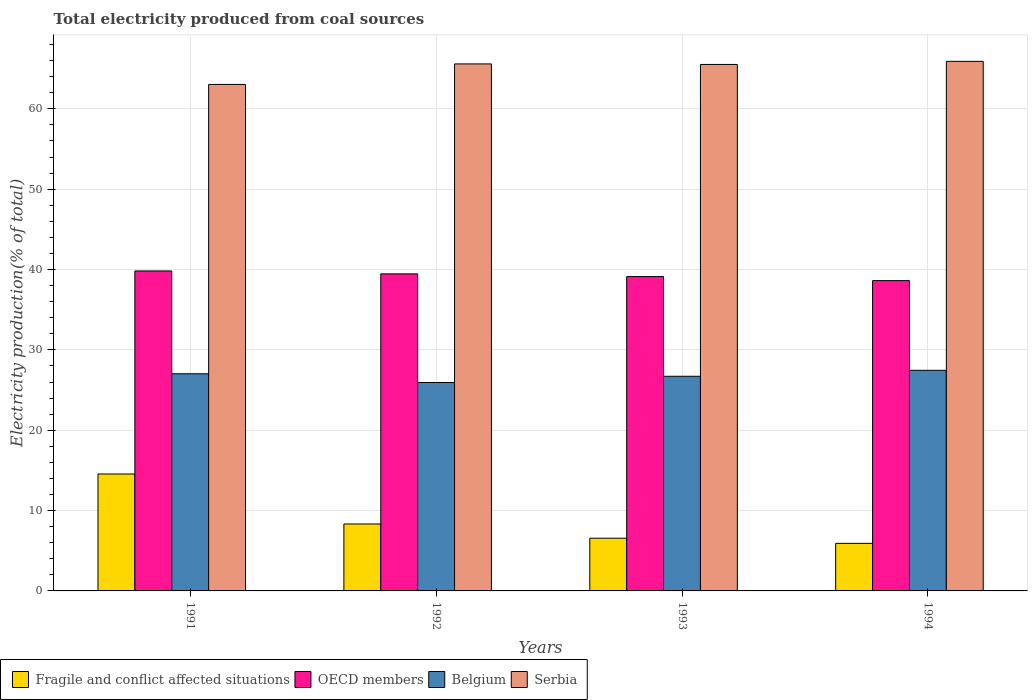How many groups of bars are there?
Your response must be concise. 4. Are the number of bars per tick equal to the number of legend labels?
Your answer should be very brief. Yes. Are the number of bars on each tick of the X-axis equal?
Your answer should be compact. Yes. In how many cases, is the number of bars for a given year not equal to the number of legend labels?
Give a very brief answer. 0. What is the total electricity produced in Serbia in 1993?
Ensure brevity in your answer.  65.52. Across all years, what is the maximum total electricity produced in Belgium?
Your response must be concise. 27.45. Across all years, what is the minimum total electricity produced in Fragile and conflict affected situations?
Provide a succinct answer. 5.92. In which year was the total electricity produced in Belgium minimum?
Make the answer very short. 1992. What is the total total electricity produced in OECD members in the graph?
Make the answer very short. 157.02. What is the difference between the total electricity produced in Belgium in 1993 and that in 1994?
Your response must be concise. -0.74. What is the difference between the total electricity produced in Serbia in 1992 and the total electricity produced in Fragile and conflict affected situations in 1991?
Ensure brevity in your answer.  51.04. What is the average total electricity produced in Serbia per year?
Give a very brief answer. 65.01. In the year 1992, what is the difference between the total electricity produced in OECD members and total electricity produced in Serbia?
Your answer should be compact. -26.13. In how many years, is the total electricity produced in Belgium greater than 20 %?
Make the answer very short. 4. What is the ratio of the total electricity produced in Fragile and conflict affected situations in 1991 to that in 1992?
Keep it short and to the point. 1.75. What is the difference between the highest and the second highest total electricity produced in Fragile and conflict affected situations?
Make the answer very short. 6.22. What is the difference between the highest and the lowest total electricity produced in Serbia?
Ensure brevity in your answer.  2.87. Is it the case that in every year, the sum of the total electricity produced in OECD members and total electricity produced in Serbia is greater than the sum of total electricity produced in Belgium and total electricity produced in Fragile and conflict affected situations?
Your answer should be very brief. No. What does the 3rd bar from the left in 1992 represents?
Make the answer very short. Belgium. Is it the case that in every year, the sum of the total electricity produced in Serbia and total electricity produced in Fragile and conflict affected situations is greater than the total electricity produced in Belgium?
Offer a terse response. Yes. Are all the bars in the graph horizontal?
Ensure brevity in your answer.  No. How many years are there in the graph?
Your answer should be very brief. 4. Does the graph contain grids?
Keep it short and to the point. Yes. Where does the legend appear in the graph?
Provide a short and direct response. Bottom left. How are the legend labels stacked?
Your response must be concise. Horizontal. What is the title of the graph?
Make the answer very short. Total electricity produced from coal sources. Does "Dominican Republic" appear as one of the legend labels in the graph?
Give a very brief answer. No. What is the Electricity production(% of total) of Fragile and conflict affected situations in 1991?
Give a very brief answer. 14.55. What is the Electricity production(% of total) in OECD members in 1991?
Offer a terse response. 39.82. What is the Electricity production(% of total) of Belgium in 1991?
Offer a very short reply. 27.03. What is the Electricity production(% of total) in Serbia in 1991?
Your response must be concise. 63.04. What is the Electricity production(% of total) of Fragile and conflict affected situations in 1992?
Give a very brief answer. 8.33. What is the Electricity production(% of total) in OECD members in 1992?
Ensure brevity in your answer.  39.46. What is the Electricity production(% of total) of Belgium in 1992?
Your answer should be very brief. 25.94. What is the Electricity production(% of total) in Serbia in 1992?
Your answer should be compact. 65.59. What is the Electricity production(% of total) in Fragile and conflict affected situations in 1993?
Your answer should be compact. 6.56. What is the Electricity production(% of total) in OECD members in 1993?
Your answer should be compact. 39.12. What is the Electricity production(% of total) of Belgium in 1993?
Offer a terse response. 26.71. What is the Electricity production(% of total) of Serbia in 1993?
Provide a short and direct response. 65.52. What is the Electricity production(% of total) in Fragile and conflict affected situations in 1994?
Provide a short and direct response. 5.92. What is the Electricity production(% of total) of OECD members in 1994?
Keep it short and to the point. 38.62. What is the Electricity production(% of total) of Belgium in 1994?
Offer a very short reply. 27.45. What is the Electricity production(% of total) of Serbia in 1994?
Your answer should be compact. 65.91. Across all years, what is the maximum Electricity production(% of total) of Fragile and conflict affected situations?
Keep it short and to the point. 14.55. Across all years, what is the maximum Electricity production(% of total) of OECD members?
Keep it short and to the point. 39.82. Across all years, what is the maximum Electricity production(% of total) in Belgium?
Offer a terse response. 27.45. Across all years, what is the maximum Electricity production(% of total) of Serbia?
Provide a succinct answer. 65.91. Across all years, what is the minimum Electricity production(% of total) of Fragile and conflict affected situations?
Provide a short and direct response. 5.92. Across all years, what is the minimum Electricity production(% of total) of OECD members?
Offer a very short reply. 38.62. Across all years, what is the minimum Electricity production(% of total) of Belgium?
Ensure brevity in your answer.  25.94. Across all years, what is the minimum Electricity production(% of total) of Serbia?
Ensure brevity in your answer.  63.04. What is the total Electricity production(% of total) in Fragile and conflict affected situations in the graph?
Provide a short and direct response. 35.36. What is the total Electricity production(% of total) of OECD members in the graph?
Offer a very short reply. 157.02. What is the total Electricity production(% of total) of Belgium in the graph?
Your answer should be compact. 107.13. What is the total Electricity production(% of total) of Serbia in the graph?
Make the answer very short. 260.05. What is the difference between the Electricity production(% of total) of Fragile and conflict affected situations in 1991 and that in 1992?
Ensure brevity in your answer.  6.22. What is the difference between the Electricity production(% of total) of OECD members in 1991 and that in 1992?
Keep it short and to the point. 0.36. What is the difference between the Electricity production(% of total) of Belgium in 1991 and that in 1992?
Provide a short and direct response. 1.09. What is the difference between the Electricity production(% of total) of Serbia in 1991 and that in 1992?
Ensure brevity in your answer.  -2.55. What is the difference between the Electricity production(% of total) in Fragile and conflict affected situations in 1991 and that in 1993?
Make the answer very short. 7.99. What is the difference between the Electricity production(% of total) in OECD members in 1991 and that in 1993?
Offer a very short reply. 0.7. What is the difference between the Electricity production(% of total) of Belgium in 1991 and that in 1993?
Keep it short and to the point. 0.31. What is the difference between the Electricity production(% of total) in Serbia in 1991 and that in 1993?
Your answer should be very brief. -2.48. What is the difference between the Electricity production(% of total) of Fragile and conflict affected situations in 1991 and that in 1994?
Your answer should be compact. 8.63. What is the difference between the Electricity production(% of total) of OECD members in 1991 and that in 1994?
Provide a succinct answer. 1.2. What is the difference between the Electricity production(% of total) of Belgium in 1991 and that in 1994?
Provide a succinct answer. -0.43. What is the difference between the Electricity production(% of total) of Serbia in 1991 and that in 1994?
Give a very brief answer. -2.87. What is the difference between the Electricity production(% of total) of Fragile and conflict affected situations in 1992 and that in 1993?
Give a very brief answer. 1.77. What is the difference between the Electricity production(% of total) of OECD members in 1992 and that in 1993?
Make the answer very short. 0.34. What is the difference between the Electricity production(% of total) in Belgium in 1992 and that in 1993?
Give a very brief answer. -0.77. What is the difference between the Electricity production(% of total) in Serbia in 1992 and that in 1993?
Provide a succinct answer. 0.07. What is the difference between the Electricity production(% of total) in Fragile and conflict affected situations in 1992 and that in 1994?
Your answer should be compact. 2.41. What is the difference between the Electricity production(% of total) of OECD members in 1992 and that in 1994?
Make the answer very short. 0.84. What is the difference between the Electricity production(% of total) of Belgium in 1992 and that in 1994?
Your answer should be very brief. -1.51. What is the difference between the Electricity production(% of total) in Serbia in 1992 and that in 1994?
Ensure brevity in your answer.  -0.32. What is the difference between the Electricity production(% of total) of Fragile and conflict affected situations in 1993 and that in 1994?
Your response must be concise. 0.64. What is the difference between the Electricity production(% of total) in OECD members in 1993 and that in 1994?
Your response must be concise. 0.5. What is the difference between the Electricity production(% of total) of Belgium in 1993 and that in 1994?
Offer a terse response. -0.74. What is the difference between the Electricity production(% of total) of Serbia in 1993 and that in 1994?
Provide a short and direct response. -0.39. What is the difference between the Electricity production(% of total) in Fragile and conflict affected situations in 1991 and the Electricity production(% of total) in OECD members in 1992?
Provide a short and direct response. -24.91. What is the difference between the Electricity production(% of total) of Fragile and conflict affected situations in 1991 and the Electricity production(% of total) of Belgium in 1992?
Your answer should be compact. -11.39. What is the difference between the Electricity production(% of total) of Fragile and conflict affected situations in 1991 and the Electricity production(% of total) of Serbia in 1992?
Your response must be concise. -51.04. What is the difference between the Electricity production(% of total) of OECD members in 1991 and the Electricity production(% of total) of Belgium in 1992?
Offer a terse response. 13.88. What is the difference between the Electricity production(% of total) of OECD members in 1991 and the Electricity production(% of total) of Serbia in 1992?
Keep it short and to the point. -25.77. What is the difference between the Electricity production(% of total) in Belgium in 1991 and the Electricity production(% of total) in Serbia in 1992?
Offer a terse response. -38.56. What is the difference between the Electricity production(% of total) in Fragile and conflict affected situations in 1991 and the Electricity production(% of total) in OECD members in 1993?
Offer a terse response. -24.57. What is the difference between the Electricity production(% of total) in Fragile and conflict affected situations in 1991 and the Electricity production(% of total) in Belgium in 1993?
Offer a very short reply. -12.16. What is the difference between the Electricity production(% of total) of Fragile and conflict affected situations in 1991 and the Electricity production(% of total) of Serbia in 1993?
Keep it short and to the point. -50.97. What is the difference between the Electricity production(% of total) of OECD members in 1991 and the Electricity production(% of total) of Belgium in 1993?
Make the answer very short. 13.11. What is the difference between the Electricity production(% of total) of OECD members in 1991 and the Electricity production(% of total) of Serbia in 1993?
Provide a succinct answer. -25.7. What is the difference between the Electricity production(% of total) of Belgium in 1991 and the Electricity production(% of total) of Serbia in 1993?
Make the answer very short. -38.5. What is the difference between the Electricity production(% of total) of Fragile and conflict affected situations in 1991 and the Electricity production(% of total) of OECD members in 1994?
Provide a short and direct response. -24.07. What is the difference between the Electricity production(% of total) of Fragile and conflict affected situations in 1991 and the Electricity production(% of total) of Belgium in 1994?
Ensure brevity in your answer.  -12.9. What is the difference between the Electricity production(% of total) in Fragile and conflict affected situations in 1991 and the Electricity production(% of total) in Serbia in 1994?
Offer a terse response. -51.36. What is the difference between the Electricity production(% of total) in OECD members in 1991 and the Electricity production(% of total) in Belgium in 1994?
Make the answer very short. 12.37. What is the difference between the Electricity production(% of total) in OECD members in 1991 and the Electricity production(% of total) in Serbia in 1994?
Offer a very short reply. -26.09. What is the difference between the Electricity production(% of total) of Belgium in 1991 and the Electricity production(% of total) of Serbia in 1994?
Provide a succinct answer. -38.88. What is the difference between the Electricity production(% of total) of Fragile and conflict affected situations in 1992 and the Electricity production(% of total) of OECD members in 1993?
Offer a very short reply. -30.79. What is the difference between the Electricity production(% of total) in Fragile and conflict affected situations in 1992 and the Electricity production(% of total) in Belgium in 1993?
Give a very brief answer. -18.38. What is the difference between the Electricity production(% of total) of Fragile and conflict affected situations in 1992 and the Electricity production(% of total) of Serbia in 1993?
Offer a terse response. -57.19. What is the difference between the Electricity production(% of total) of OECD members in 1992 and the Electricity production(% of total) of Belgium in 1993?
Your answer should be very brief. 12.74. What is the difference between the Electricity production(% of total) of OECD members in 1992 and the Electricity production(% of total) of Serbia in 1993?
Ensure brevity in your answer.  -26.06. What is the difference between the Electricity production(% of total) in Belgium in 1992 and the Electricity production(% of total) in Serbia in 1993?
Provide a succinct answer. -39.58. What is the difference between the Electricity production(% of total) of Fragile and conflict affected situations in 1992 and the Electricity production(% of total) of OECD members in 1994?
Keep it short and to the point. -30.29. What is the difference between the Electricity production(% of total) in Fragile and conflict affected situations in 1992 and the Electricity production(% of total) in Belgium in 1994?
Your answer should be compact. -19.12. What is the difference between the Electricity production(% of total) of Fragile and conflict affected situations in 1992 and the Electricity production(% of total) of Serbia in 1994?
Offer a terse response. -57.58. What is the difference between the Electricity production(% of total) of OECD members in 1992 and the Electricity production(% of total) of Belgium in 1994?
Ensure brevity in your answer.  12. What is the difference between the Electricity production(% of total) in OECD members in 1992 and the Electricity production(% of total) in Serbia in 1994?
Your answer should be very brief. -26.45. What is the difference between the Electricity production(% of total) of Belgium in 1992 and the Electricity production(% of total) of Serbia in 1994?
Keep it short and to the point. -39.97. What is the difference between the Electricity production(% of total) in Fragile and conflict affected situations in 1993 and the Electricity production(% of total) in OECD members in 1994?
Your answer should be very brief. -32.06. What is the difference between the Electricity production(% of total) of Fragile and conflict affected situations in 1993 and the Electricity production(% of total) of Belgium in 1994?
Your answer should be compact. -20.89. What is the difference between the Electricity production(% of total) in Fragile and conflict affected situations in 1993 and the Electricity production(% of total) in Serbia in 1994?
Your answer should be compact. -59.35. What is the difference between the Electricity production(% of total) in OECD members in 1993 and the Electricity production(% of total) in Belgium in 1994?
Give a very brief answer. 11.67. What is the difference between the Electricity production(% of total) of OECD members in 1993 and the Electricity production(% of total) of Serbia in 1994?
Your answer should be very brief. -26.79. What is the difference between the Electricity production(% of total) in Belgium in 1993 and the Electricity production(% of total) in Serbia in 1994?
Your answer should be very brief. -39.19. What is the average Electricity production(% of total) of Fragile and conflict affected situations per year?
Make the answer very short. 8.84. What is the average Electricity production(% of total) in OECD members per year?
Your response must be concise. 39.25. What is the average Electricity production(% of total) of Belgium per year?
Give a very brief answer. 26.78. What is the average Electricity production(% of total) in Serbia per year?
Your response must be concise. 65.01. In the year 1991, what is the difference between the Electricity production(% of total) in Fragile and conflict affected situations and Electricity production(% of total) in OECD members?
Your answer should be compact. -25.27. In the year 1991, what is the difference between the Electricity production(% of total) of Fragile and conflict affected situations and Electricity production(% of total) of Belgium?
Your answer should be very brief. -12.47. In the year 1991, what is the difference between the Electricity production(% of total) of Fragile and conflict affected situations and Electricity production(% of total) of Serbia?
Your answer should be very brief. -48.49. In the year 1991, what is the difference between the Electricity production(% of total) in OECD members and Electricity production(% of total) in Belgium?
Offer a very short reply. 12.79. In the year 1991, what is the difference between the Electricity production(% of total) in OECD members and Electricity production(% of total) in Serbia?
Your answer should be very brief. -23.22. In the year 1991, what is the difference between the Electricity production(% of total) of Belgium and Electricity production(% of total) of Serbia?
Ensure brevity in your answer.  -36.01. In the year 1992, what is the difference between the Electricity production(% of total) in Fragile and conflict affected situations and Electricity production(% of total) in OECD members?
Provide a short and direct response. -31.13. In the year 1992, what is the difference between the Electricity production(% of total) in Fragile and conflict affected situations and Electricity production(% of total) in Belgium?
Keep it short and to the point. -17.61. In the year 1992, what is the difference between the Electricity production(% of total) of Fragile and conflict affected situations and Electricity production(% of total) of Serbia?
Your answer should be compact. -57.26. In the year 1992, what is the difference between the Electricity production(% of total) in OECD members and Electricity production(% of total) in Belgium?
Your answer should be very brief. 13.52. In the year 1992, what is the difference between the Electricity production(% of total) in OECD members and Electricity production(% of total) in Serbia?
Provide a succinct answer. -26.13. In the year 1992, what is the difference between the Electricity production(% of total) of Belgium and Electricity production(% of total) of Serbia?
Make the answer very short. -39.65. In the year 1993, what is the difference between the Electricity production(% of total) of Fragile and conflict affected situations and Electricity production(% of total) of OECD members?
Offer a terse response. -32.56. In the year 1993, what is the difference between the Electricity production(% of total) of Fragile and conflict affected situations and Electricity production(% of total) of Belgium?
Give a very brief answer. -20.15. In the year 1993, what is the difference between the Electricity production(% of total) in Fragile and conflict affected situations and Electricity production(% of total) in Serbia?
Provide a succinct answer. -58.96. In the year 1993, what is the difference between the Electricity production(% of total) of OECD members and Electricity production(% of total) of Belgium?
Your response must be concise. 12.41. In the year 1993, what is the difference between the Electricity production(% of total) of OECD members and Electricity production(% of total) of Serbia?
Provide a succinct answer. -26.4. In the year 1993, what is the difference between the Electricity production(% of total) in Belgium and Electricity production(% of total) in Serbia?
Provide a succinct answer. -38.81. In the year 1994, what is the difference between the Electricity production(% of total) in Fragile and conflict affected situations and Electricity production(% of total) in OECD members?
Provide a succinct answer. -32.7. In the year 1994, what is the difference between the Electricity production(% of total) in Fragile and conflict affected situations and Electricity production(% of total) in Belgium?
Provide a short and direct response. -21.53. In the year 1994, what is the difference between the Electricity production(% of total) in Fragile and conflict affected situations and Electricity production(% of total) in Serbia?
Offer a terse response. -59.99. In the year 1994, what is the difference between the Electricity production(% of total) in OECD members and Electricity production(% of total) in Belgium?
Ensure brevity in your answer.  11.16. In the year 1994, what is the difference between the Electricity production(% of total) in OECD members and Electricity production(% of total) in Serbia?
Your response must be concise. -27.29. In the year 1994, what is the difference between the Electricity production(% of total) of Belgium and Electricity production(% of total) of Serbia?
Your answer should be compact. -38.45. What is the ratio of the Electricity production(% of total) in Fragile and conflict affected situations in 1991 to that in 1992?
Provide a succinct answer. 1.75. What is the ratio of the Electricity production(% of total) of OECD members in 1991 to that in 1992?
Make the answer very short. 1.01. What is the ratio of the Electricity production(% of total) of Belgium in 1991 to that in 1992?
Your answer should be very brief. 1.04. What is the ratio of the Electricity production(% of total) in Serbia in 1991 to that in 1992?
Your answer should be compact. 0.96. What is the ratio of the Electricity production(% of total) in Fragile and conflict affected situations in 1991 to that in 1993?
Ensure brevity in your answer.  2.22. What is the ratio of the Electricity production(% of total) of OECD members in 1991 to that in 1993?
Your response must be concise. 1.02. What is the ratio of the Electricity production(% of total) in Belgium in 1991 to that in 1993?
Provide a succinct answer. 1.01. What is the ratio of the Electricity production(% of total) in Serbia in 1991 to that in 1993?
Ensure brevity in your answer.  0.96. What is the ratio of the Electricity production(% of total) in Fragile and conflict affected situations in 1991 to that in 1994?
Give a very brief answer. 2.46. What is the ratio of the Electricity production(% of total) in OECD members in 1991 to that in 1994?
Your answer should be very brief. 1.03. What is the ratio of the Electricity production(% of total) in Belgium in 1991 to that in 1994?
Give a very brief answer. 0.98. What is the ratio of the Electricity production(% of total) in Serbia in 1991 to that in 1994?
Ensure brevity in your answer.  0.96. What is the ratio of the Electricity production(% of total) in Fragile and conflict affected situations in 1992 to that in 1993?
Provide a short and direct response. 1.27. What is the ratio of the Electricity production(% of total) of OECD members in 1992 to that in 1993?
Make the answer very short. 1.01. What is the ratio of the Electricity production(% of total) in Fragile and conflict affected situations in 1992 to that in 1994?
Your answer should be very brief. 1.41. What is the ratio of the Electricity production(% of total) of OECD members in 1992 to that in 1994?
Provide a succinct answer. 1.02. What is the ratio of the Electricity production(% of total) of Belgium in 1992 to that in 1994?
Offer a very short reply. 0.94. What is the ratio of the Electricity production(% of total) of Fragile and conflict affected situations in 1993 to that in 1994?
Give a very brief answer. 1.11. What is the ratio of the Electricity production(% of total) of OECD members in 1993 to that in 1994?
Your response must be concise. 1.01. What is the ratio of the Electricity production(% of total) of Serbia in 1993 to that in 1994?
Your answer should be very brief. 0.99. What is the difference between the highest and the second highest Electricity production(% of total) in Fragile and conflict affected situations?
Your answer should be very brief. 6.22. What is the difference between the highest and the second highest Electricity production(% of total) of OECD members?
Your response must be concise. 0.36. What is the difference between the highest and the second highest Electricity production(% of total) in Belgium?
Keep it short and to the point. 0.43. What is the difference between the highest and the second highest Electricity production(% of total) in Serbia?
Provide a succinct answer. 0.32. What is the difference between the highest and the lowest Electricity production(% of total) of Fragile and conflict affected situations?
Ensure brevity in your answer.  8.63. What is the difference between the highest and the lowest Electricity production(% of total) in OECD members?
Offer a very short reply. 1.2. What is the difference between the highest and the lowest Electricity production(% of total) in Belgium?
Provide a short and direct response. 1.51. What is the difference between the highest and the lowest Electricity production(% of total) of Serbia?
Offer a very short reply. 2.87. 